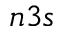Convert formula to latex. <formula><loc_0><loc_0><loc_500><loc_500>n 3 s</formula> 